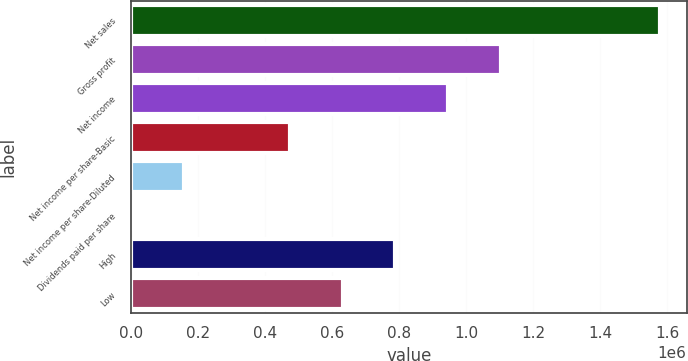Convert chart. <chart><loc_0><loc_0><loc_500><loc_500><bar_chart><fcel>Net sales<fcel>Gross profit<fcel>Net income<fcel>Net income per share-Basic<fcel>Net income per share-Diluted<fcel>Dividends paid per share<fcel>High<fcel>Low<nl><fcel>1.57835e+06<fcel>1.10485e+06<fcel>947010<fcel>473505<fcel>157835<fcel>0.48<fcel>789175<fcel>631340<nl></chart> 